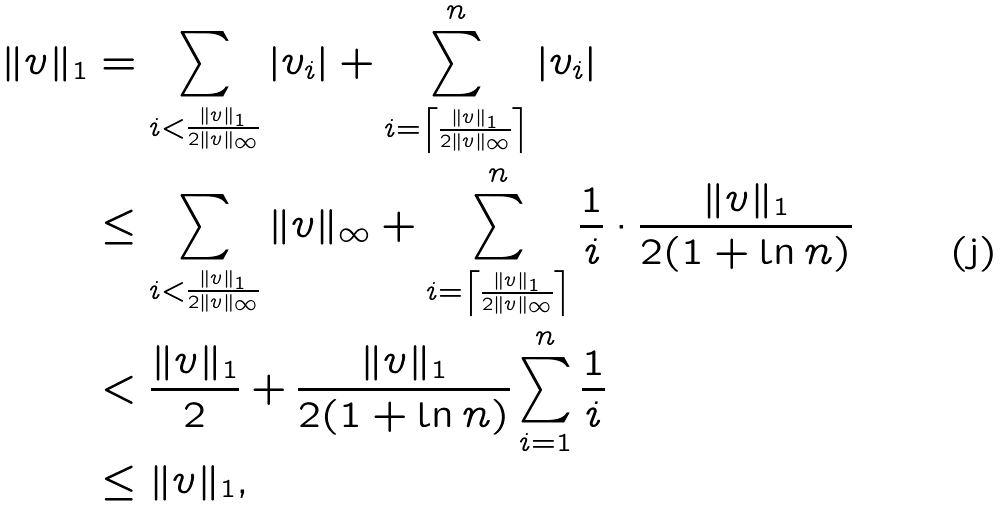Convert formula to latex. <formula><loc_0><loc_0><loc_500><loc_500>\| v \| _ { 1 } & = \sum _ { i < \frac { \| v \| _ { 1 } } { 2 \| v \| _ { \infty } } } | v _ { i } | + \sum _ { i = \left \lceil \frac { \| v \| _ { 1 } } { 2 \| v \| _ { \infty } } \right \rceil } ^ { n } | v _ { i } | \\ & \leq \sum _ { i < \frac { \| v \| _ { 1 } } { 2 \| v \| _ { \infty } } } \| v \| _ { \infty } + \sum _ { i = \left \lceil \frac { \| v \| _ { 1 } } { 2 \| v \| _ { \infty } } \right \rceil } ^ { n } \frac { 1 } { i } \cdot \frac { \| v \| _ { 1 } } { 2 ( 1 + \ln n ) } \\ & < \frac { \| v \| _ { 1 } } { 2 } + \frac { \| v \| _ { 1 } } { 2 ( 1 + \ln n ) } \sum _ { i = 1 } ^ { n } \frac { 1 } { i } \\ & \leq \| v \| _ { 1 } ,</formula> 